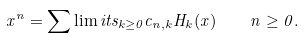Convert formula to latex. <formula><loc_0><loc_0><loc_500><loc_500>x ^ { n } = \sum \lim i t s _ { k \geq 0 } c _ { n , k } H _ { k } ( x ) \quad n \geq 0 .</formula> 